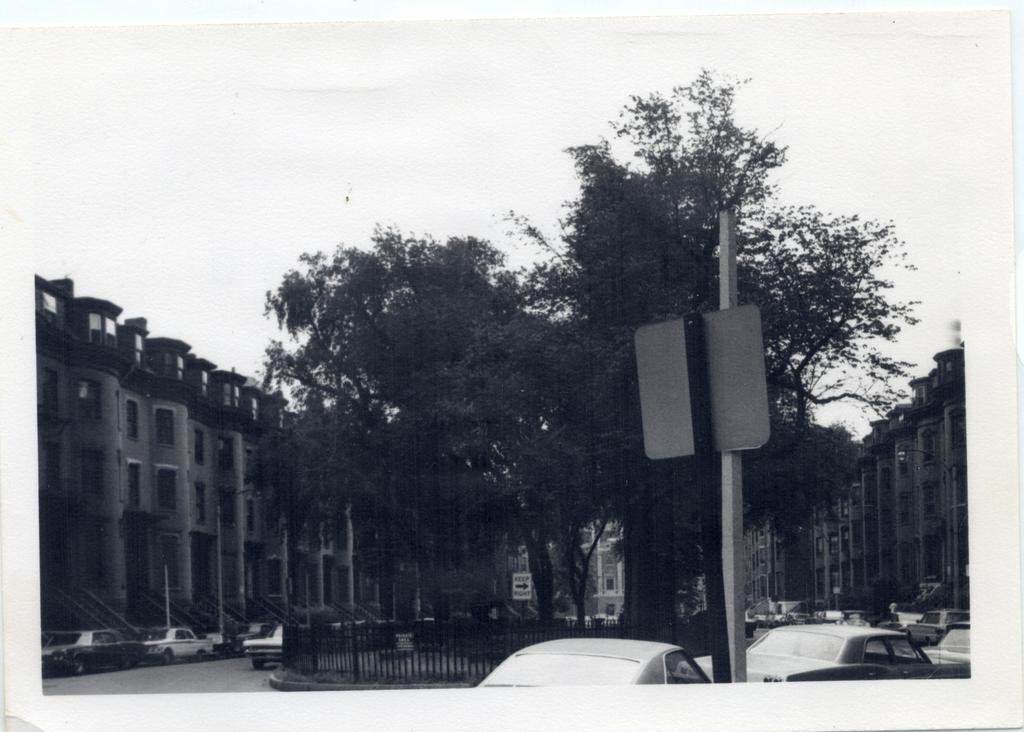How would you summarize this image in a sentence or two? In this image, we can photo of a picture. There are buildings and trees in the middle of the image. There are cars on the road. There is a pole in the bottom right of the image. In the background of the image, there is a sky. 